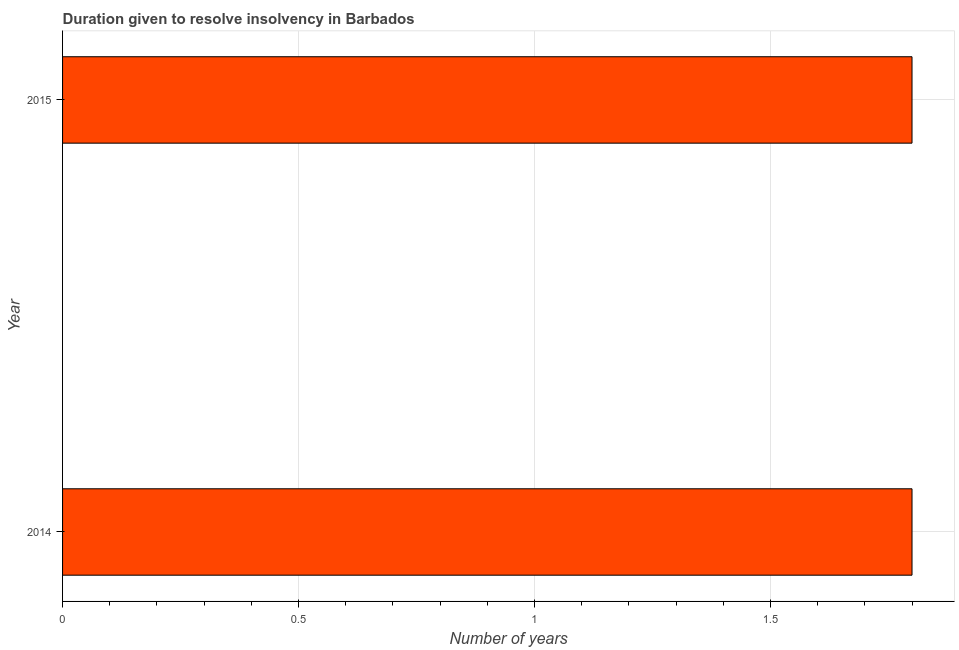Does the graph contain any zero values?
Your answer should be compact. No. Does the graph contain grids?
Your response must be concise. Yes. What is the title of the graph?
Offer a very short reply. Duration given to resolve insolvency in Barbados. What is the label or title of the X-axis?
Offer a terse response. Number of years. What is the number of years to resolve insolvency in 2015?
Offer a terse response. 1.8. Across all years, what is the maximum number of years to resolve insolvency?
Make the answer very short. 1.8. In which year was the number of years to resolve insolvency maximum?
Your answer should be compact. 2014. In which year was the number of years to resolve insolvency minimum?
Provide a short and direct response. 2014. What is the difference between the number of years to resolve insolvency in 2014 and 2015?
Make the answer very short. 0. What is the median number of years to resolve insolvency?
Offer a terse response. 1.8. In how many years, is the number of years to resolve insolvency greater than 0.3 ?
Your response must be concise. 2. Is the number of years to resolve insolvency in 2014 less than that in 2015?
Make the answer very short. No. How many years are there in the graph?
Offer a very short reply. 2. What is the difference between two consecutive major ticks on the X-axis?
Your response must be concise. 0.5. What is the Number of years of 2014?
Make the answer very short. 1.8. 